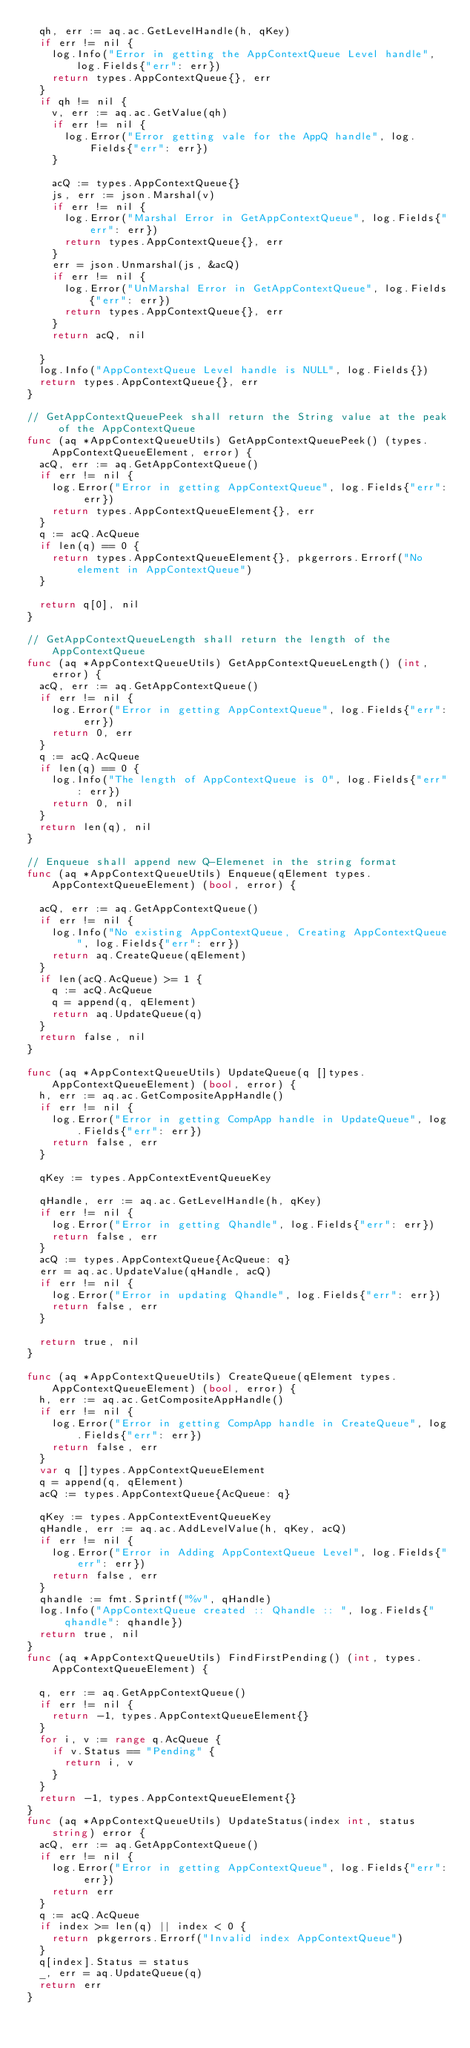Convert code to text. <code><loc_0><loc_0><loc_500><loc_500><_Go_>	qh, err := aq.ac.GetLevelHandle(h, qKey)
	if err != nil {
		log.Info("Error in getting the AppContextQueue Level handle", log.Fields{"err": err})
		return types.AppContextQueue{}, err
	}
	if qh != nil {
		v, err := aq.ac.GetValue(qh)
		if err != nil {
			log.Error("Error getting vale for the AppQ handle", log.Fields{"err": err})
		}

		acQ := types.AppContextQueue{}
		js, err := json.Marshal(v)
		if err != nil {
			log.Error("Marshal Error in GetAppContextQueue", log.Fields{"err": err})
			return types.AppContextQueue{}, err
		}
		err = json.Unmarshal(js, &acQ)
		if err != nil {
			log.Error("UnMarshal Error in GetAppContextQueue", log.Fields{"err": err})
			return types.AppContextQueue{}, err
		}
		return acQ, nil

	}
	log.Info("AppContextQueue Level handle is NULL", log.Fields{})
	return types.AppContextQueue{}, err
}

// GetAppContextQueuePeek shall return the String value at the peak of the AppContextQueue
func (aq *AppContextQueueUtils) GetAppContextQueuePeek() (types.AppContextQueueElement, error) {
	acQ, err := aq.GetAppContextQueue()
	if err != nil {
		log.Error("Error in getting AppContextQueue", log.Fields{"err": err})
		return types.AppContextQueueElement{}, err
	}
	q := acQ.AcQueue
	if len(q) == 0 {
		return types.AppContextQueueElement{}, pkgerrors.Errorf("No element in AppContextQueue")
	}

	return q[0], nil
}

// GetAppContextQueueLength shall return the length of the AppContextQueue
func (aq *AppContextQueueUtils) GetAppContextQueueLength() (int, error) {
	acQ, err := aq.GetAppContextQueue()
	if err != nil {
		log.Error("Error in getting AppContextQueue", log.Fields{"err": err})
		return 0, err
	}
	q := acQ.AcQueue
	if len(q) == 0 {
		log.Info("The length of AppContextQueue is 0", log.Fields{"err": err})
		return 0, nil
	}
	return len(q), nil
}

// Enqueue shall append new Q-Elemenet in the string format
func (aq *AppContextQueueUtils) Enqueue(qElement types.AppContextQueueElement) (bool, error) {

	acQ, err := aq.GetAppContextQueue()
	if err != nil {
		log.Info("No existing AppContextQueue, Creating AppContextQueue", log.Fields{"err": err})
		return aq.CreateQueue(qElement)
	}
	if len(acQ.AcQueue) >= 1 {
		q := acQ.AcQueue
		q = append(q, qElement)
		return aq.UpdateQueue(q)
	}
	return false, nil
}

func (aq *AppContextQueueUtils) UpdateQueue(q []types.AppContextQueueElement) (bool, error) {
	h, err := aq.ac.GetCompositeAppHandle()
	if err != nil {
		log.Error("Error in getting CompApp handle in UpdateQueue", log.Fields{"err": err})
		return false, err
	}

	qKey := types.AppContextEventQueueKey

	qHandle, err := aq.ac.GetLevelHandle(h, qKey)
	if err != nil {
		log.Error("Error in getting Qhandle", log.Fields{"err": err})
		return false, err
	}
	acQ := types.AppContextQueue{AcQueue: q}
	err = aq.ac.UpdateValue(qHandle, acQ)
	if err != nil {
		log.Error("Error in updating Qhandle", log.Fields{"err": err})
		return false, err
	}

	return true, nil
}

func (aq *AppContextQueueUtils) CreateQueue(qElement types.AppContextQueueElement) (bool, error) {
	h, err := aq.ac.GetCompositeAppHandle()
	if err != nil {
		log.Error("Error in getting CompApp handle in CreateQueue", log.Fields{"err": err})
		return false, err
	}
	var q []types.AppContextQueueElement
	q = append(q, qElement)
	acQ := types.AppContextQueue{AcQueue: q}

	qKey := types.AppContextEventQueueKey
	qHandle, err := aq.ac.AddLevelValue(h, qKey, acQ)
	if err != nil {
		log.Error("Error in Adding AppContextQueue Level", log.Fields{"err": err})
		return false, err
	}
	qhandle := fmt.Sprintf("%v", qHandle)
	log.Info("AppContextQueue created :: Qhandle :: ", log.Fields{"qhandle": qhandle})
	return true, nil
}
func (aq *AppContextQueueUtils) FindFirstPending() (int, types.AppContextQueueElement) {

	q, err := aq.GetAppContextQueue()
	if err != nil {
		return -1, types.AppContextQueueElement{}
	}
	for i, v := range q.AcQueue {
		if v.Status == "Pending" {
			return i, v
		}
	}
	return -1, types.AppContextQueueElement{}
}
func (aq *AppContextQueueUtils) UpdateStatus(index int, status string) error {
	acQ, err := aq.GetAppContextQueue()
	if err != nil {
		log.Error("Error in getting AppContextQueue", log.Fields{"err": err})
		return err
	}
	q := acQ.AcQueue
	if index >= len(q) || index < 0 {
		return pkgerrors.Errorf("Invalid index AppContextQueue")
	}
	q[index].Status = status
	_, err = aq.UpdateQueue(q)
	return err
}
</code> 